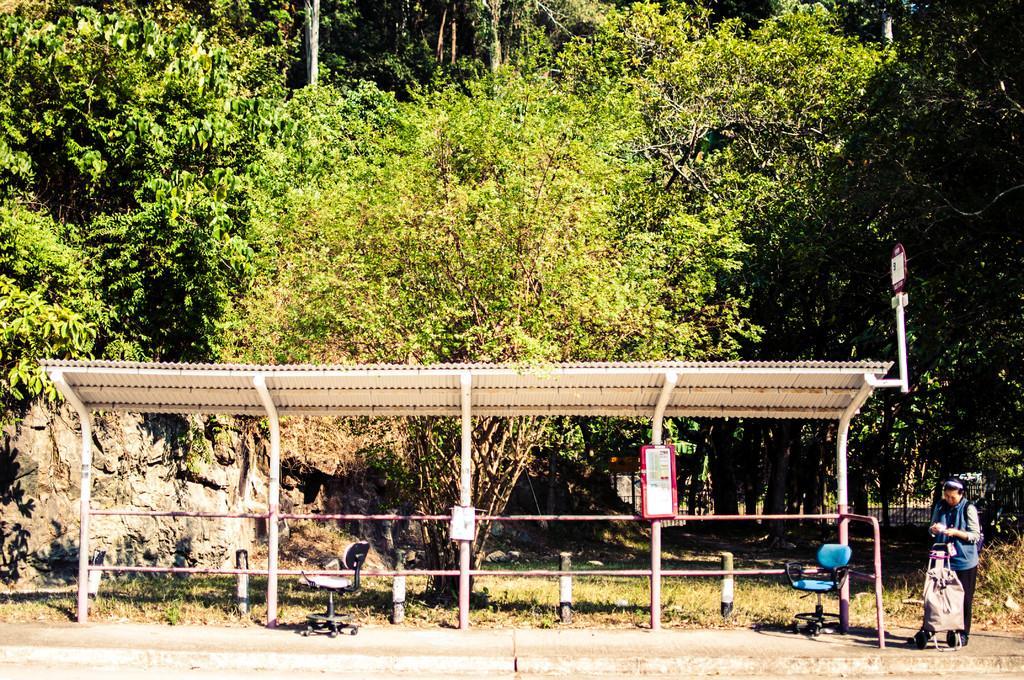In one or two sentences, can you explain what this image depicts? On the right side of the image we can see a person, in front of person we can find a bag, in the middle of the image we can find few chairs under the shelter, in the background we can see fence and few trees. 